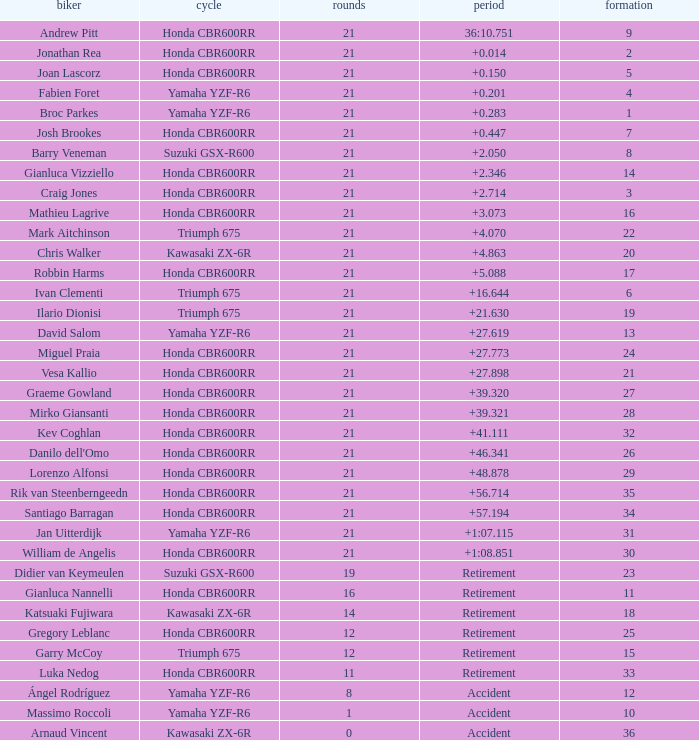What driver had the highest grid position with a time of +0.283? 1.0. 